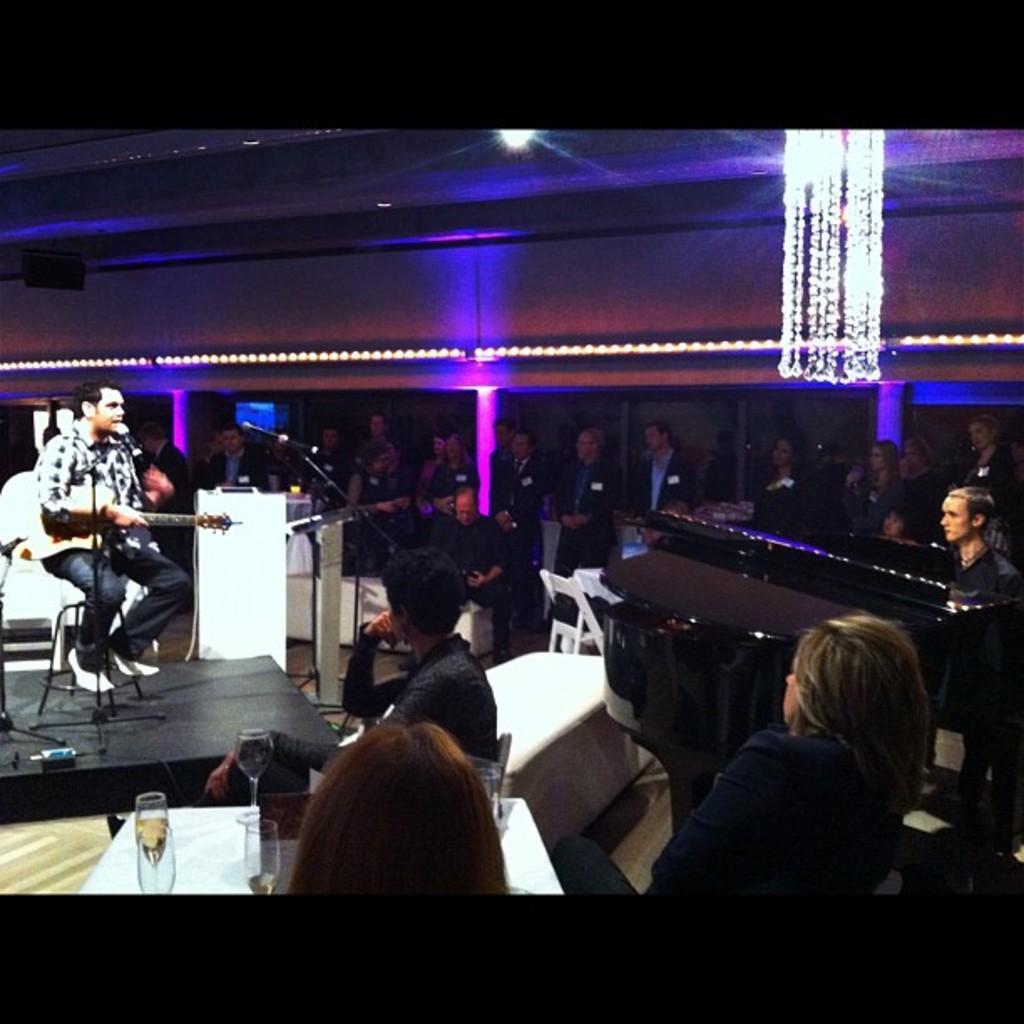Please provide a concise description of this image. In this image I can see on the left side a man is sitting on the chair and playing the guitar, at the bottom few people are observing these things, at the top there are lights. 